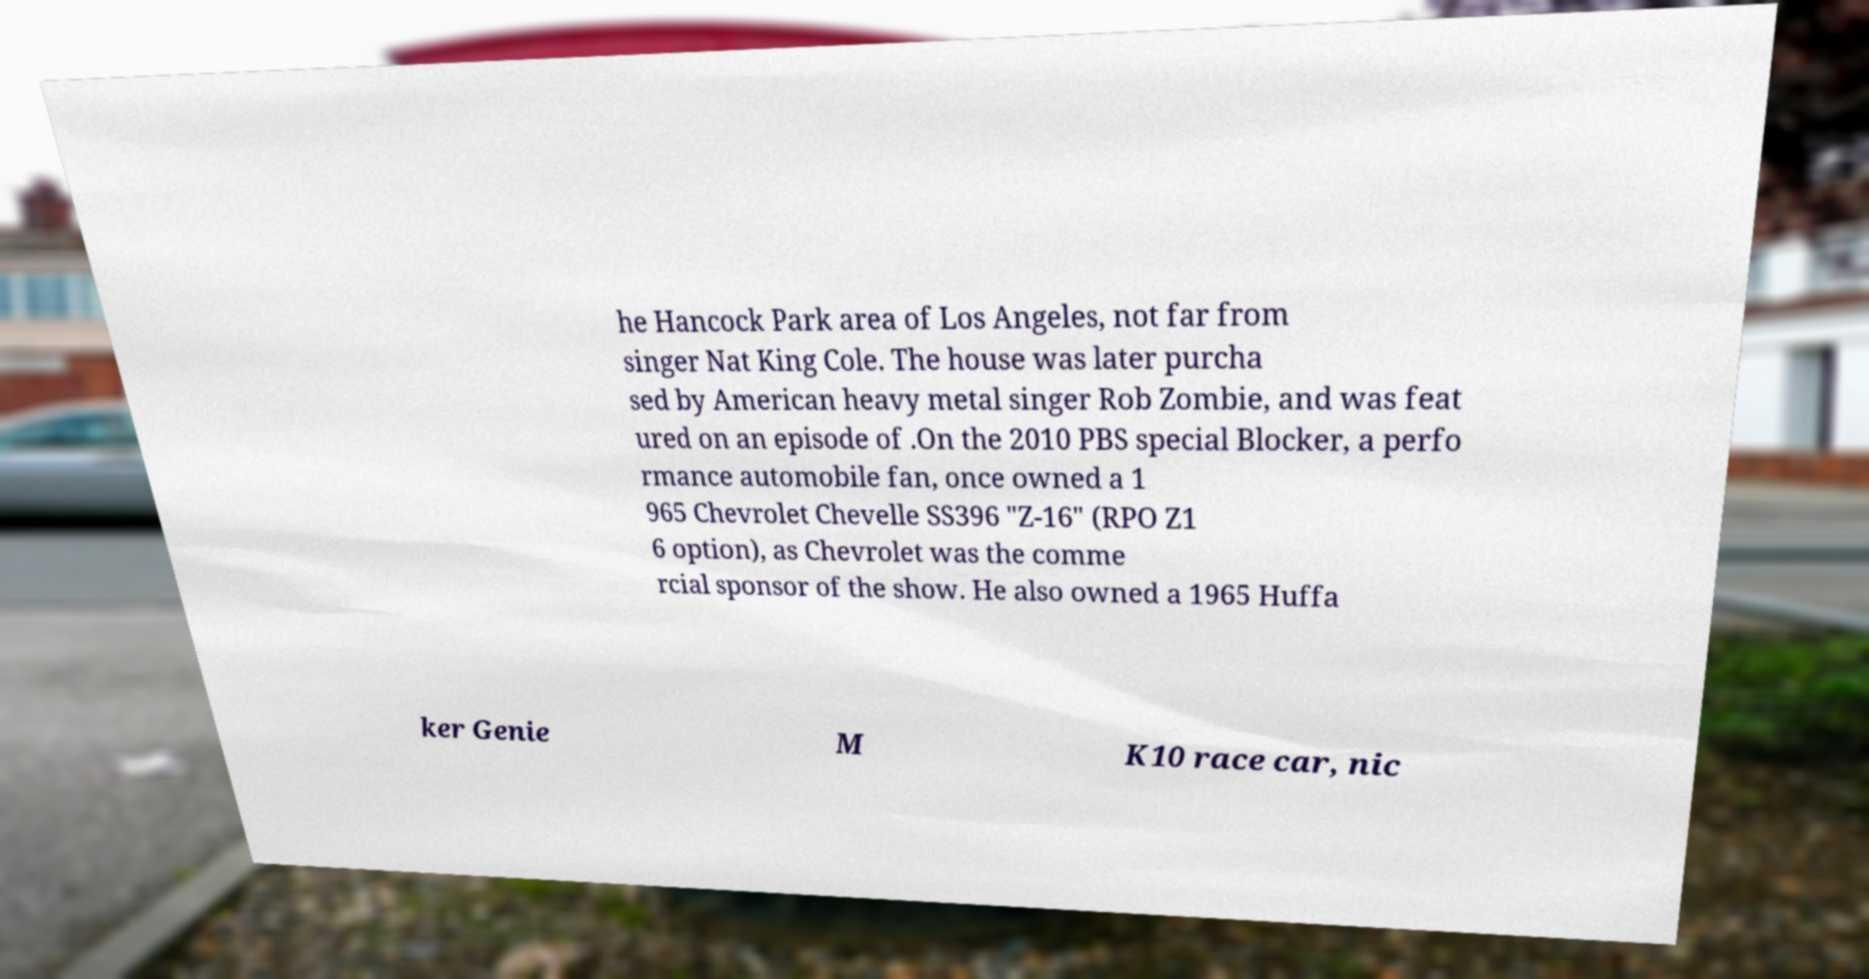Please identify and transcribe the text found in this image. he Hancock Park area of Los Angeles, not far from singer Nat King Cole. The house was later purcha sed by American heavy metal singer Rob Zombie, and was feat ured on an episode of .On the 2010 PBS special Blocker, a perfo rmance automobile fan, once owned a 1 965 Chevrolet Chevelle SS396 "Z-16" (RPO Z1 6 option), as Chevrolet was the comme rcial sponsor of the show. He also owned a 1965 Huffa ker Genie M K10 race car, nic 